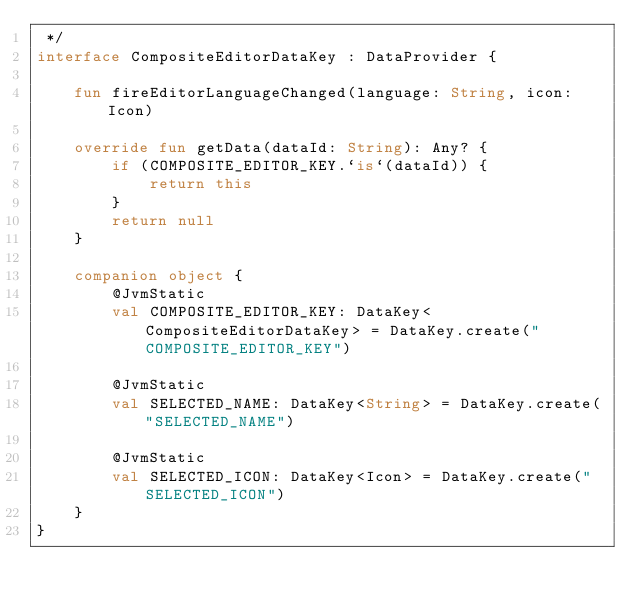<code> <loc_0><loc_0><loc_500><loc_500><_Kotlin_> */
interface CompositeEditorDataKey : DataProvider {

    fun fireEditorLanguageChanged(language: String, icon: Icon)

    override fun getData(dataId: String): Any? {
        if (COMPOSITE_EDITOR_KEY.`is`(dataId)) {
            return this
        }
        return null
    }

    companion object {
        @JvmStatic
        val COMPOSITE_EDITOR_KEY: DataKey<CompositeEditorDataKey> = DataKey.create("COMPOSITE_EDITOR_KEY")

        @JvmStatic
        val SELECTED_NAME: DataKey<String> = DataKey.create("SELECTED_NAME")

        @JvmStatic
        val SELECTED_ICON: DataKey<Icon> = DataKey.create("SELECTED_ICON")
    }
}</code> 